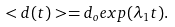<formula> <loc_0><loc_0><loc_500><loc_500>< d ( t ) > = d _ { o } e x p ( \lambda _ { 1 } t ) .</formula> 